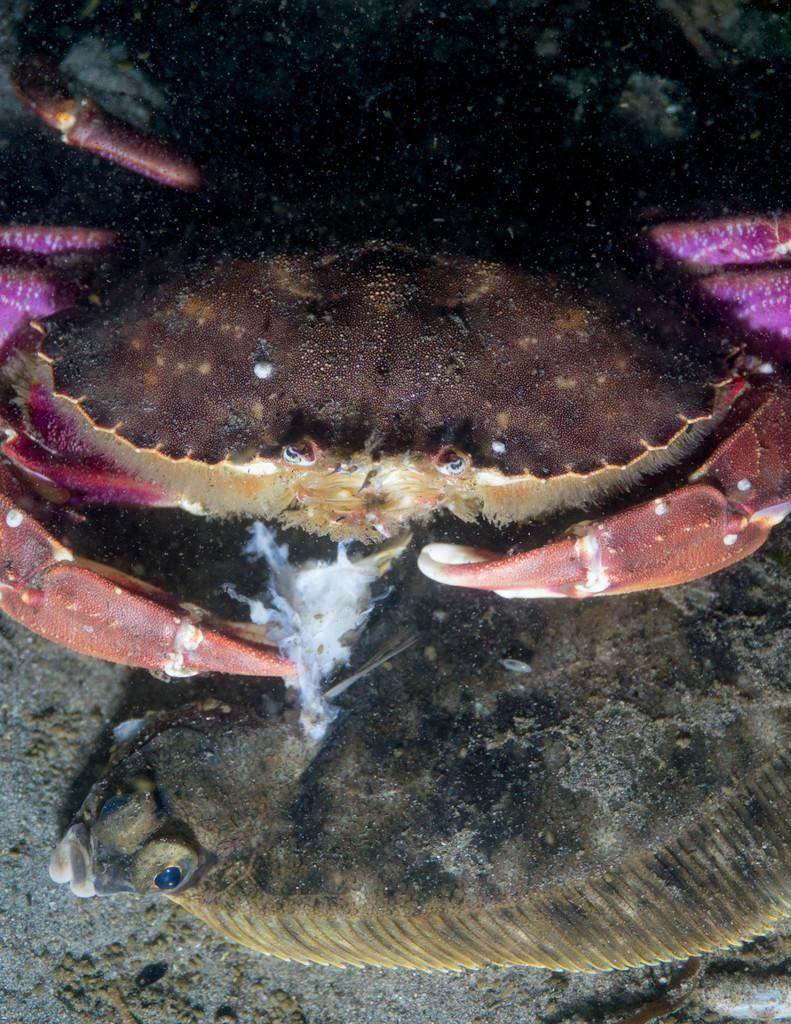What type of animals can be seen in the image? There are water animals in the image. Where are the water animals located? The water animals are in water. What is visible at the bottom of the image? There is a floor visible at the bottom of the image. How many brothers are present in the image? There are no brothers mentioned or visible in the image. What type of wind can be seen blowing in the image? There is no wind present in the image; it features water animals in water. 